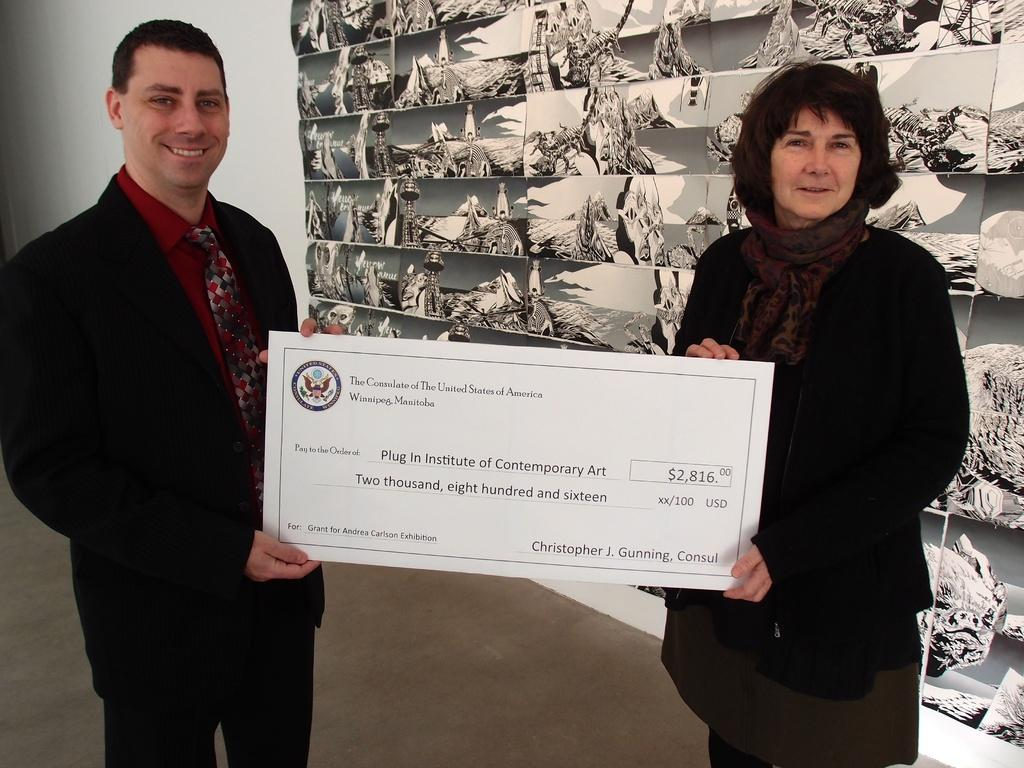How many people are in the image? There are two people in the image. What are the two people doing in the image? The two people are standing and holding a white color board. Can you describe the clothing of the two people? The two people are wearing different color dress. What can be seen in the background of the image? There is a white wall and a different background visible in the image. What type of music can be heard coming from the turkey in the image? There is no turkey present in the image, and therefore no music can be heard coming from it. 